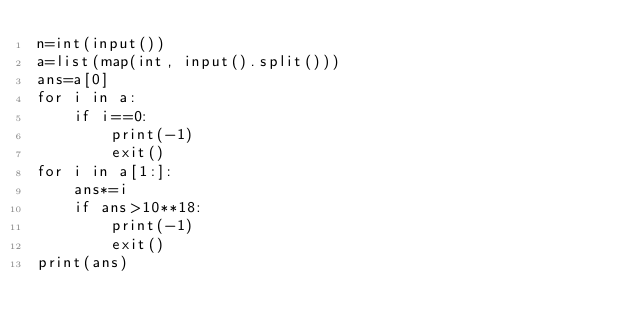Convert code to text. <code><loc_0><loc_0><loc_500><loc_500><_Python_>n=int(input())
a=list(map(int, input().split()))
ans=a[0]
for i in a:
    if i==0:
        print(-1)
        exit()
for i in a[1:]:
    ans*=i
    if ans>10**18:
        print(-1)
        exit()
print(ans)</code> 